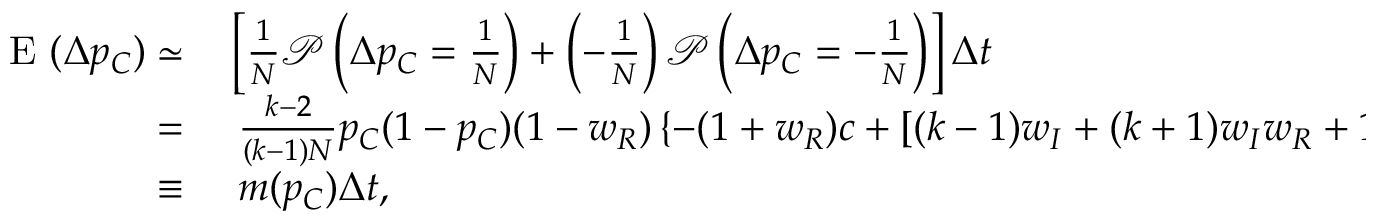<formula> <loc_0><loc_0><loc_500><loc_500>\begin{array} { r l } { E ( \Delta p _ { C } ) \simeq } & \left [ \frac { 1 } { N } \mathcal { P } \left ( \Delta p _ { C } = \frac { 1 } { N } \right ) + \left ( - \frac { 1 } { N } \right ) \mathcal { P } \left ( \Delta p _ { C } = - \frac { 1 } { N } \right ) \right ] \Delta t } \\ { = } & \frac { k - 2 } { ( k - 1 ) N } p _ { C } ( 1 - p _ { C } ) ( 1 - w _ { R } ) \left \{ - ( 1 + w _ { R } ) c + [ ( k - 1 ) w _ { I } + ( k + 1 ) w _ { I } w _ { R } + 1 - w _ { R } ] b / k \right \} \delta \Delta t } \\ { \equiv } & m ( p _ { C } ) \Delta t , } \end{array}</formula> 